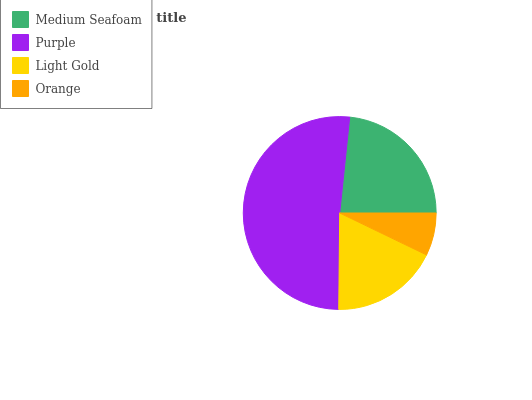Is Orange the minimum?
Answer yes or no. Yes. Is Purple the maximum?
Answer yes or no. Yes. Is Light Gold the minimum?
Answer yes or no. No. Is Light Gold the maximum?
Answer yes or no. No. Is Purple greater than Light Gold?
Answer yes or no. Yes. Is Light Gold less than Purple?
Answer yes or no. Yes. Is Light Gold greater than Purple?
Answer yes or no. No. Is Purple less than Light Gold?
Answer yes or no. No. Is Medium Seafoam the high median?
Answer yes or no. Yes. Is Light Gold the low median?
Answer yes or no. Yes. Is Purple the high median?
Answer yes or no. No. Is Purple the low median?
Answer yes or no. No. 